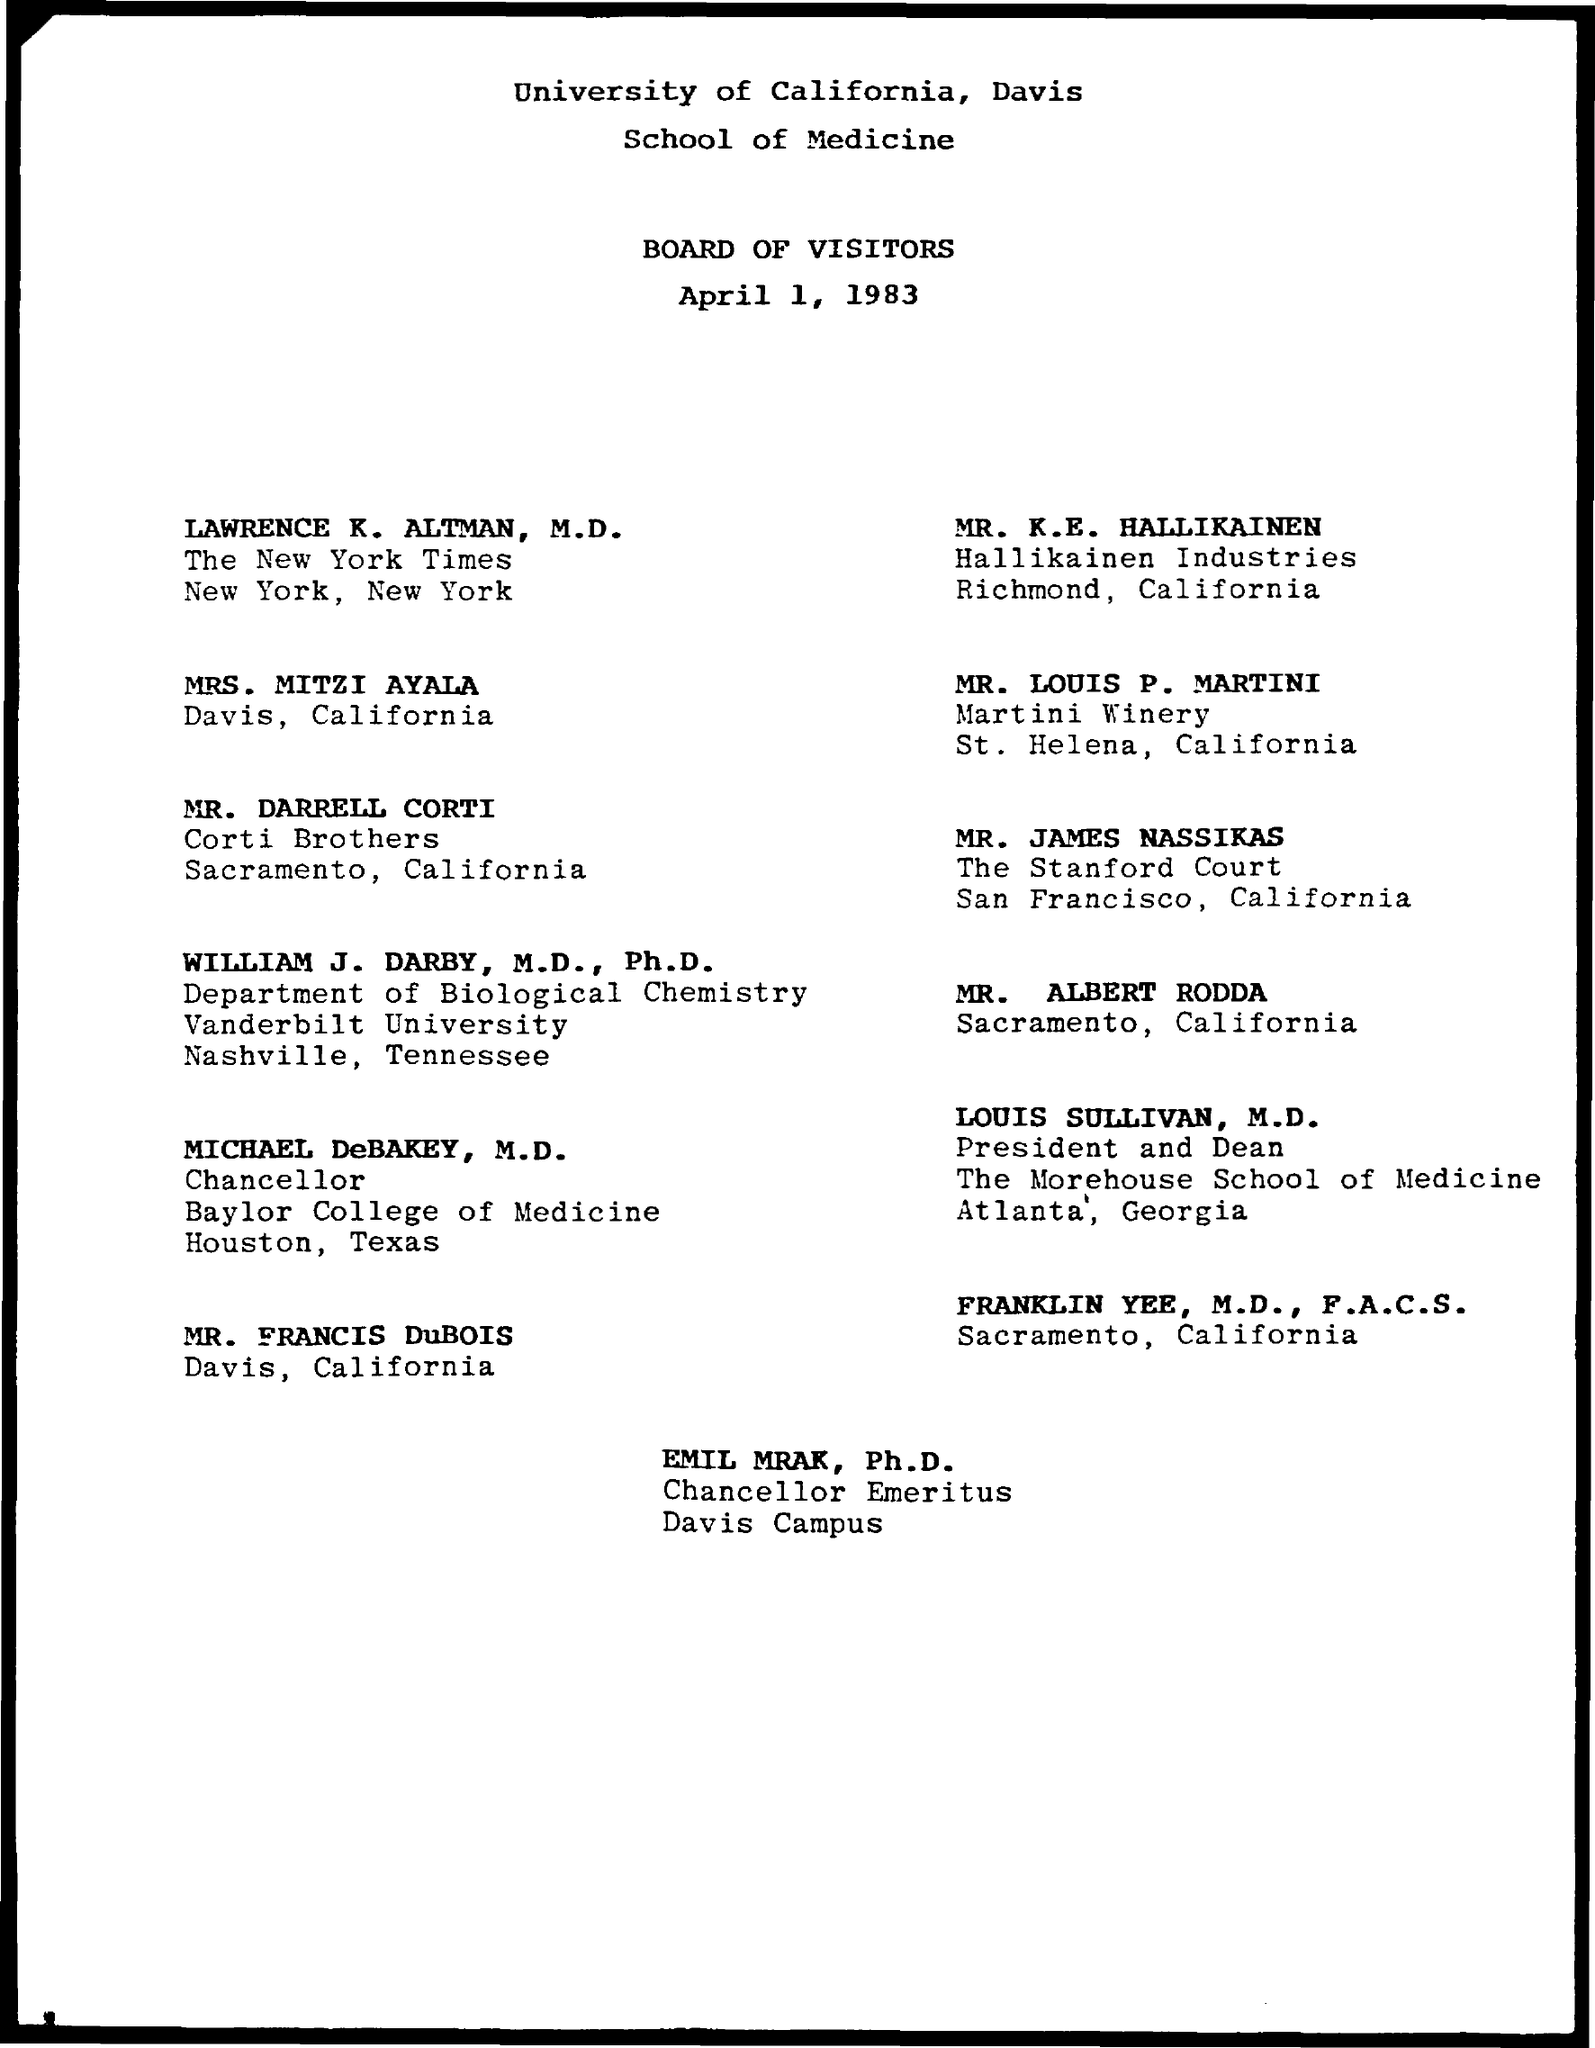What is the date mentioned ?
Provide a succinct answer. April 1, 1983. Who is the chancellor of emeritus
Offer a terse response. Emil Mrak. 